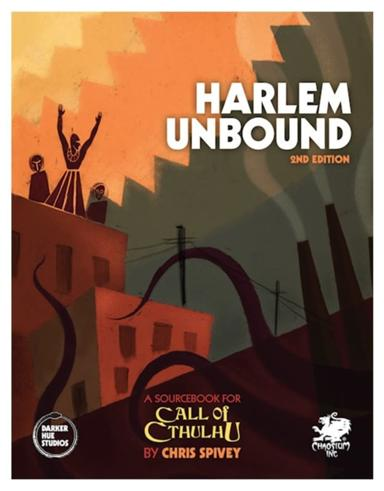How does 'Harlem Unbound' integrate the historical elements of the Harlem Renaissance with the fictional Cthulhu Mythos? 'Harlem Unbound' masterfully blends factual history with the fictional Cthulhu Mythos by positioning the game's narratives in real historical contexts. Players encounter real historical figures and events that are seamlessly integrated with the folklore and cosmic horror of Lovecraft's universe. This integration allows players to engage deeply with the social issues and cultural dynamism of the 1920s while contending with the otherworldly forces typical of the Mythos, providing a rich, layered experience. Yes, 'Harlem Unbound' addresses themes like racial discrimination, artistic expression, and social change, reflecting the struggles and achievements of the African-American community during the Harlem Renaissance. By weaving these serious themes into its gameplay through scenarios and character interactions, the game encourages players to reflect on these historical issues while engaging with the mythic elements. 